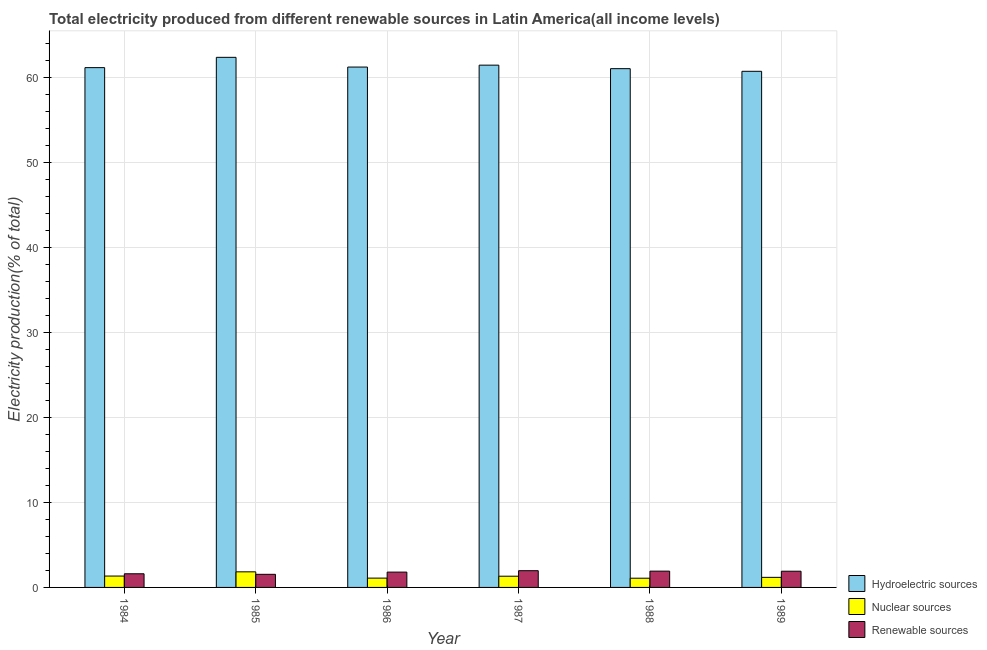How many groups of bars are there?
Your answer should be compact. 6. How many bars are there on the 3rd tick from the left?
Keep it short and to the point. 3. What is the percentage of electricity produced by hydroelectric sources in 1988?
Ensure brevity in your answer.  61.08. Across all years, what is the maximum percentage of electricity produced by nuclear sources?
Offer a terse response. 1.83. Across all years, what is the minimum percentage of electricity produced by renewable sources?
Offer a very short reply. 1.54. What is the total percentage of electricity produced by nuclear sources in the graph?
Keep it short and to the point. 7.86. What is the difference between the percentage of electricity produced by hydroelectric sources in 1985 and that in 1988?
Your answer should be very brief. 1.33. What is the difference between the percentage of electricity produced by renewable sources in 1985 and the percentage of electricity produced by nuclear sources in 1986?
Give a very brief answer. -0.26. What is the average percentage of electricity produced by renewable sources per year?
Your answer should be very brief. 1.79. In the year 1989, what is the difference between the percentage of electricity produced by hydroelectric sources and percentage of electricity produced by nuclear sources?
Provide a short and direct response. 0. In how many years, is the percentage of electricity produced by renewable sources greater than 58 %?
Keep it short and to the point. 0. What is the ratio of the percentage of electricity produced by hydroelectric sources in 1988 to that in 1989?
Offer a very short reply. 1.01. Is the percentage of electricity produced by renewable sources in 1986 less than that in 1987?
Make the answer very short. Yes. Is the difference between the percentage of electricity produced by hydroelectric sources in 1986 and 1987 greater than the difference between the percentage of electricity produced by renewable sources in 1986 and 1987?
Offer a terse response. No. What is the difference between the highest and the second highest percentage of electricity produced by hydroelectric sources?
Your response must be concise. 0.92. What is the difference between the highest and the lowest percentage of electricity produced by renewable sources?
Your answer should be very brief. 0.43. What does the 3rd bar from the left in 1985 represents?
Your response must be concise. Renewable sources. What does the 3rd bar from the right in 1987 represents?
Keep it short and to the point. Hydroelectric sources. Is it the case that in every year, the sum of the percentage of electricity produced by hydroelectric sources and percentage of electricity produced by nuclear sources is greater than the percentage of electricity produced by renewable sources?
Your response must be concise. Yes. Are all the bars in the graph horizontal?
Your answer should be compact. No. How many years are there in the graph?
Your answer should be very brief. 6. What is the difference between two consecutive major ticks on the Y-axis?
Your answer should be compact. 10. How are the legend labels stacked?
Keep it short and to the point. Vertical. What is the title of the graph?
Offer a very short reply. Total electricity produced from different renewable sources in Latin America(all income levels). Does "Fuel" appear as one of the legend labels in the graph?
Your response must be concise. No. What is the Electricity production(% of total) of Hydroelectric sources in 1984?
Keep it short and to the point. 61.2. What is the Electricity production(% of total) of Nuclear sources in 1984?
Provide a short and direct response. 1.34. What is the Electricity production(% of total) in Renewable sources in 1984?
Give a very brief answer. 1.61. What is the Electricity production(% of total) of Hydroelectric sources in 1985?
Give a very brief answer. 62.41. What is the Electricity production(% of total) of Nuclear sources in 1985?
Keep it short and to the point. 1.83. What is the Electricity production(% of total) of Renewable sources in 1985?
Make the answer very short. 1.54. What is the Electricity production(% of total) of Hydroelectric sources in 1986?
Provide a short and direct response. 61.26. What is the Electricity production(% of total) of Nuclear sources in 1986?
Your answer should be very brief. 1.1. What is the Electricity production(% of total) in Renewable sources in 1986?
Your answer should be very brief. 1.8. What is the Electricity production(% of total) in Hydroelectric sources in 1987?
Provide a short and direct response. 61.49. What is the Electricity production(% of total) in Nuclear sources in 1987?
Offer a very short reply. 1.32. What is the Electricity production(% of total) in Renewable sources in 1987?
Ensure brevity in your answer.  1.97. What is the Electricity production(% of total) of Hydroelectric sources in 1988?
Ensure brevity in your answer.  61.08. What is the Electricity production(% of total) in Nuclear sources in 1988?
Keep it short and to the point. 1.09. What is the Electricity production(% of total) of Renewable sources in 1988?
Give a very brief answer. 1.92. What is the Electricity production(% of total) of Hydroelectric sources in 1989?
Your answer should be very brief. 60.76. What is the Electricity production(% of total) of Nuclear sources in 1989?
Provide a short and direct response. 1.19. What is the Electricity production(% of total) of Renewable sources in 1989?
Offer a very short reply. 1.91. Across all years, what is the maximum Electricity production(% of total) in Hydroelectric sources?
Your response must be concise. 62.41. Across all years, what is the maximum Electricity production(% of total) in Nuclear sources?
Ensure brevity in your answer.  1.83. Across all years, what is the maximum Electricity production(% of total) in Renewable sources?
Provide a succinct answer. 1.97. Across all years, what is the minimum Electricity production(% of total) of Hydroelectric sources?
Provide a succinct answer. 60.76. Across all years, what is the minimum Electricity production(% of total) of Nuclear sources?
Your answer should be very brief. 1.09. Across all years, what is the minimum Electricity production(% of total) of Renewable sources?
Ensure brevity in your answer.  1.54. What is the total Electricity production(% of total) of Hydroelectric sources in the graph?
Your response must be concise. 368.2. What is the total Electricity production(% of total) in Nuclear sources in the graph?
Your answer should be very brief. 7.86. What is the total Electricity production(% of total) in Renewable sources in the graph?
Provide a short and direct response. 10.75. What is the difference between the Electricity production(% of total) of Hydroelectric sources in 1984 and that in 1985?
Your response must be concise. -1.21. What is the difference between the Electricity production(% of total) of Nuclear sources in 1984 and that in 1985?
Your response must be concise. -0.5. What is the difference between the Electricity production(% of total) of Renewable sources in 1984 and that in 1985?
Ensure brevity in your answer.  0.06. What is the difference between the Electricity production(% of total) in Hydroelectric sources in 1984 and that in 1986?
Keep it short and to the point. -0.07. What is the difference between the Electricity production(% of total) of Nuclear sources in 1984 and that in 1986?
Make the answer very short. 0.24. What is the difference between the Electricity production(% of total) in Renewable sources in 1984 and that in 1986?
Give a very brief answer. -0.2. What is the difference between the Electricity production(% of total) of Hydroelectric sources in 1984 and that in 1987?
Give a very brief answer. -0.29. What is the difference between the Electricity production(% of total) in Nuclear sources in 1984 and that in 1987?
Make the answer very short. 0.02. What is the difference between the Electricity production(% of total) in Renewable sources in 1984 and that in 1987?
Your answer should be compact. -0.36. What is the difference between the Electricity production(% of total) in Hydroelectric sources in 1984 and that in 1988?
Keep it short and to the point. 0.12. What is the difference between the Electricity production(% of total) in Nuclear sources in 1984 and that in 1988?
Keep it short and to the point. 0.25. What is the difference between the Electricity production(% of total) in Renewable sources in 1984 and that in 1988?
Your answer should be compact. -0.31. What is the difference between the Electricity production(% of total) in Hydroelectric sources in 1984 and that in 1989?
Keep it short and to the point. 0.43. What is the difference between the Electricity production(% of total) in Nuclear sources in 1984 and that in 1989?
Ensure brevity in your answer.  0.15. What is the difference between the Electricity production(% of total) in Renewable sources in 1984 and that in 1989?
Keep it short and to the point. -0.3. What is the difference between the Electricity production(% of total) in Hydroelectric sources in 1985 and that in 1986?
Your answer should be compact. 1.15. What is the difference between the Electricity production(% of total) in Nuclear sources in 1985 and that in 1986?
Your answer should be compact. 0.74. What is the difference between the Electricity production(% of total) of Renewable sources in 1985 and that in 1986?
Keep it short and to the point. -0.26. What is the difference between the Electricity production(% of total) of Hydroelectric sources in 1985 and that in 1987?
Provide a short and direct response. 0.92. What is the difference between the Electricity production(% of total) in Nuclear sources in 1985 and that in 1987?
Offer a very short reply. 0.52. What is the difference between the Electricity production(% of total) of Renewable sources in 1985 and that in 1987?
Provide a succinct answer. -0.43. What is the difference between the Electricity production(% of total) in Hydroelectric sources in 1985 and that in 1988?
Provide a succinct answer. 1.33. What is the difference between the Electricity production(% of total) of Nuclear sources in 1985 and that in 1988?
Your answer should be very brief. 0.75. What is the difference between the Electricity production(% of total) in Renewable sources in 1985 and that in 1988?
Give a very brief answer. -0.38. What is the difference between the Electricity production(% of total) of Hydroelectric sources in 1985 and that in 1989?
Offer a terse response. 1.65. What is the difference between the Electricity production(% of total) in Nuclear sources in 1985 and that in 1989?
Offer a terse response. 0.65. What is the difference between the Electricity production(% of total) in Renewable sources in 1985 and that in 1989?
Provide a short and direct response. -0.37. What is the difference between the Electricity production(% of total) in Hydroelectric sources in 1986 and that in 1987?
Provide a short and direct response. -0.23. What is the difference between the Electricity production(% of total) of Nuclear sources in 1986 and that in 1987?
Give a very brief answer. -0.22. What is the difference between the Electricity production(% of total) of Renewable sources in 1986 and that in 1987?
Provide a succinct answer. -0.17. What is the difference between the Electricity production(% of total) in Hydroelectric sources in 1986 and that in 1988?
Provide a short and direct response. 0.19. What is the difference between the Electricity production(% of total) of Nuclear sources in 1986 and that in 1988?
Your answer should be compact. 0.01. What is the difference between the Electricity production(% of total) in Renewable sources in 1986 and that in 1988?
Provide a short and direct response. -0.12. What is the difference between the Electricity production(% of total) of Hydroelectric sources in 1986 and that in 1989?
Provide a succinct answer. 0.5. What is the difference between the Electricity production(% of total) in Nuclear sources in 1986 and that in 1989?
Provide a short and direct response. -0.09. What is the difference between the Electricity production(% of total) in Renewable sources in 1986 and that in 1989?
Provide a succinct answer. -0.11. What is the difference between the Electricity production(% of total) of Hydroelectric sources in 1987 and that in 1988?
Give a very brief answer. 0.41. What is the difference between the Electricity production(% of total) of Nuclear sources in 1987 and that in 1988?
Give a very brief answer. 0.23. What is the difference between the Electricity production(% of total) in Renewable sources in 1987 and that in 1988?
Provide a short and direct response. 0.05. What is the difference between the Electricity production(% of total) of Hydroelectric sources in 1987 and that in 1989?
Offer a terse response. 0.73. What is the difference between the Electricity production(% of total) of Nuclear sources in 1987 and that in 1989?
Give a very brief answer. 0.13. What is the difference between the Electricity production(% of total) in Renewable sources in 1987 and that in 1989?
Provide a succinct answer. 0.06. What is the difference between the Electricity production(% of total) in Hydroelectric sources in 1988 and that in 1989?
Your answer should be very brief. 0.31. What is the difference between the Electricity production(% of total) in Nuclear sources in 1988 and that in 1989?
Provide a succinct answer. -0.1. What is the difference between the Electricity production(% of total) in Renewable sources in 1988 and that in 1989?
Provide a short and direct response. 0.01. What is the difference between the Electricity production(% of total) in Hydroelectric sources in 1984 and the Electricity production(% of total) in Nuclear sources in 1985?
Your answer should be compact. 59.36. What is the difference between the Electricity production(% of total) of Hydroelectric sources in 1984 and the Electricity production(% of total) of Renewable sources in 1985?
Your answer should be compact. 59.65. What is the difference between the Electricity production(% of total) in Nuclear sources in 1984 and the Electricity production(% of total) in Renewable sources in 1985?
Offer a terse response. -0.2. What is the difference between the Electricity production(% of total) of Hydroelectric sources in 1984 and the Electricity production(% of total) of Nuclear sources in 1986?
Your answer should be very brief. 60.1. What is the difference between the Electricity production(% of total) of Hydroelectric sources in 1984 and the Electricity production(% of total) of Renewable sources in 1986?
Offer a very short reply. 59.39. What is the difference between the Electricity production(% of total) in Nuclear sources in 1984 and the Electricity production(% of total) in Renewable sources in 1986?
Your answer should be very brief. -0.46. What is the difference between the Electricity production(% of total) of Hydroelectric sources in 1984 and the Electricity production(% of total) of Nuclear sources in 1987?
Ensure brevity in your answer.  59.88. What is the difference between the Electricity production(% of total) in Hydroelectric sources in 1984 and the Electricity production(% of total) in Renewable sources in 1987?
Keep it short and to the point. 59.23. What is the difference between the Electricity production(% of total) in Nuclear sources in 1984 and the Electricity production(% of total) in Renewable sources in 1987?
Offer a very short reply. -0.63. What is the difference between the Electricity production(% of total) of Hydroelectric sources in 1984 and the Electricity production(% of total) of Nuclear sources in 1988?
Give a very brief answer. 60.11. What is the difference between the Electricity production(% of total) of Hydroelectric sources in 1984 and the Electricity production(% of total) of Renewable sources in 1988?
Keep it short and to the point. 59.28. What is the difference between the Electricity production(% of total) in Nuclear sources in 1984 and the Electricity production(% of total) in Renewable sources in 1988?
Your response must be concise. -0.58. What is the difference between the Electricity production(% of total) in Hydroelectric sources in 1984 and the Electricity production(% of total) in Nuclear sources in 1989?
Provide a succinct answer. 60.01. What is the difference between the Electricity production(% of total) in Hydroelectric sources in 1984 and the Electricity production(% of total) in Renewable sources in 1989?
Your response must be concise. 59.29. What is the difference between the Electricity production(% of total) of Nuclear sources in 1984 and the Electricity production(% of total) of Renewable sources in 1989?
Provide a short and direct response. -0.57. What is the difference between the Electricity production(% of total) in Hydroelectric sources in 1985 and the Electricity production(% of total) in Nuclear sources in 1986?
Provide a short and direct response. 61.31. What is the difference between the Electricity production(% of total) of Hydroelectric sources in 1985 and the Electricity production(% of total) of Renewable sources in 1986?
Your response must be concise. 60.61. What is the difference between the Electricity production(% of total) in Nuclear sources in 1985 and the Electricity production(% of total) in Renewable sources in 1986?
Give a very brief answer. 0.03. What is the difference between the Electricity production(% of total) in Hydroelectric sources in 1985 and the Electricity production(% of total) in Nuclear sources in 1987?
Your answer should be compact. 61.09. What is the difference between the Electricity production(% of total) of Hydroelectric sources in 1985 and the Electricity production(% of total) of Renewable sources in 1987?
Provide a succinct answer. 60.44. What is the difference between the Electricity production(% of total) in Nuclear sources in 1985 and the Electricity production(% of total) in Renewable sources in 1987?
Your response must be concise. -0.14. What is the difference between the Electricity production(% of total) in Hydroelectric sources in 1985 and the Electricity production(% of total) in Nuclear sources in 1988?
Your answer should be very brief. 61.32. What is the difference between the Electricity production(% of total) of Hydroelectric sources in 1985 and the Electricity production(% of total) of Renewable sources in 1988?
Make the answer very short. 60.49. What is the difference between the Electricity production(% of total) in Nuclear sources in 1985 and the Electricity production(% of total) in Renewable sources in 1988?
Provide a short and direct response. -0.08. What is the difference between the Electricity production(% of total) in Hydroelectric sources in 1985 and the Electricity production(% of total) in Nuclear sources in 1989?
Your answer should be very brief. 61.22. What is the difference between the Electricity production(% of total) in Hydroelectric sources in 1985 and the Electricity production(% of total) in Renewable sources in 1989?
Make the answer very short. 60.5. What is the difference between the Electricity production(% of total) of Nuclear sources in 1985 and the Electricity production(% of total) of Renewable sources in 1989?
Give a very brief answer. -0.07. What is the difference between the Electricity production(% of total) of Hydroelectric sources in 1986 and the Electricity production(% of total) of Nuclear sources in 1987?
Offer a terse response. 59.95. What is the difference between the Electricity production(% of total) in Hydroelectric sources in 1986 and the Electricity production(% of total) in Renewable sources in 1987?
Provide a short and direct response. 59.29. What is the difference between the Electricity production(% of total) of Nuclear sources in 1986 and the Electricity production(% of total) of Renewable sources in 1987?
Give a very brief answer. -0.87. What is the difference between the Electricity production(% of total) in Hydroelectric sources in 1986 and the Electricity production(% of total) in Nuclear sources in 1988?
Offer a very short reply. 60.18. What is the difference between the Electricity production(% of total) in Hydroelectric sources in 1986 and the Electricity production(% of total) in Renewable sources in 1988?
Make the answer very short. 59.35. What is the difference between the Electricity production(% of total) of Nuclear sources in 1986 and the Electricity production(% of total) of Renewable sources in 1988?
Provide a short and direct response. -0.82. What is the difference between the Electricity production(% of total) in Hydroelectric sources in 1986 and the Electricity production(% of total) in Nuclear sources in 1989?
Your response must be concise. 60.08. What is the difference between the Electricity production(% of total) of Hydroelectric sources in 1986 and the Electricity production(% of total) of Renewable sources in 1989?
Your answer should be compact. 59.36. What is the difference between the Electricity production(% of total) in Nuclear sources in 1986 and the Electricity production(% of total) in Renewable sources in 1989?
Your answer should be very brief. -0.81. What is the difference between the Electricity production(% of total) in Hydroelectric sources in 1987 and the Electricity production(% of total) in Nuclear sources in 1988?
Your answer should be very brief. 60.4. What is the difference between the Electricity production(% of total) in Hydroelectric sources in 1987 and the Electricity production(% of total) in Renewable sources in 1988?
Make the answer very short. 59.57. What is the difference between the Electricity production(% of total) of Nuclear sources in 1987 and the Electricity production(% of total) of Renewable sources in 1988?
Give a very brief answer. -0.6. What is the difference between the Electricity production(% of total) of Hydroelectric sources in 1987 and the Electricity production(% of total) of Nuclear sources in 1989?
Provide a succinct answer. 60.3. What is the difference between the Electricity production(% of total) of Hydroelectric sources in 1987 and the Electricity production(% of total) of Renewable sources in 1989?
Offer a terse response. 59.58. What is the difference between the Electricity production(% of total) of Nuclear sources in 1987 and the Electricity production(% of total) of Renewable sources in 1989?
Give a very brief answer. -0.59. What is the difference between the Electricity production(% of total) in Hydroelectric sources in 1988 and the Electricity production(% of total) in Nuclear sources in 1989?
Provide a succinct answer. 59.89. What is the difference between the Electricity production(% of total) in Hydroelectric sources in 1988 and the Electricity production(% of total) in Renewable sources in 1989?
Make the answer very short. 59.17. What is the difference between the Electricity production(% of total) of Nuclear sources in 1988 and the Electricity production(% of total) of Renewable sources in 1989?
Offer a terse response. -0.82. What is the average Electricity production(% of total) in Hydroelectric sources per year?
Offer a very short reply. 61.37. What is the average Electricity production(% of total) of Nuclear sources per year?
Offer a very short reply. 1.31. What is the average Electricity production(% of total) in Renewable sources per year?
Provide a short and direct response. 1.79. In the year 1984, what is the difference between the Electricity production(% of total) in Hydroelectric sources and Electricity production(% of total) in Nuclear sources?
Ensure brevity in your answer.  59.86. In the year 1984, what is the difference between the Electricity production(% of total) in Hydroelectric sources and Electricity production(% of total) in Renewable sources?
Offer a terse response. 59.59. In the year 1984, what is the difference between the Electricity production(% of total) of Nuclear sources and Electricity production(% of total) of Renewable sources?
Your answer should be compact. -0.27. In the year 1985, what is the difference between the Electricity production(% of total) of Hydroelectric sources and Electricity production(% of total) of Nuclear sources?
Ensure brevity in your answer.  60.58. In the year 1985, what is the difference between the Electricity production(% of total) of Hydroelectric sources and Electricity production(% of total) of Renewable sources?
Keep it short and to the point. 60.87. In the year 1985, what is the difference between the Electricity production(% of total) of Nuclear sources and Electricity production(% of total) of Renewable sources?
Your answer should be very brief. 0.29. In the year 1986, what is the difference between the Electricity production(% of total) of Hydroelectric sources and Electricity production(% of total) of Nuclear sources?
Make the answer very short. 60.17. In the year 1986, what is the difference between the Electricity production(% of total) in Hydroelectric sources and Electricity production(% of total) in Renewable sources?
Make the answer very short. 59.46. In the year 1986, what is the difference between the Electricity production(% of total) of Nuclear sources and Electricity production(% of total) of Renewable sources?
Offer a terse response. -0.71. In the year 1987, what is the difference between the Electricity production(% of total) in Hydroelectric sources and Electricity production(% of total) in Nuclear sources?
Provide a short and direct response. 60.17. In the year 1987, what is the difference between the Electricity production(% of total) in Hydroelectric sources and Electricity production(% of total) in Renewable sources?
Make the answer very short. 59.52. In the year 1987, what is the difference between the Electricity production(% of total) of Nuclear sources and Electricity production(% of total) of Renewable sources?
Your response must be concise. -0.65. In the year 1988, what is the difference between the Electricity production(% of total) in Hydroelectric sources and Electricity production(% of total) in Nuclear sources?
Your answer should be compact. 59.99. In the year 1988, what is the difference between the Electricity production(% of total) in Hydroelectric sources and Electricity production(% of total) in Renewable sources?
Give a very brief answer. 59.16. In the year 1988, what is the difference between the Electricity production(% of total) in Nuclear sources and Electricity production(% of total) in Renewable sources?
Provide a succinct answer. -0.83. In the year 1989, what is the difference between the Electricity production(% of total) in Hydroelectric sources and Electricity production(% of total) in Nuclear sources?
Give a very brief answer. 59.58. In the year 1989, what is the difference between the Electricity production(% of total) of Hydroelectric sources and Electricity production(% of total) of Renewable sources?
Give a very brief answer. 58.85. In the year 1989, what is the difference between the Electricity production(% of total) in Nuclear sources and Electricity production(% of total) in Renewable sources?
Keep it short and to the point. -0.72. What is the ratio of the Electricity production(% of total) of Hydroelectric sources in 1984 to that in 1985?
Provide a succinct answer. 0.98. What is the ratio of the Electricity production(% of total) in Nuclear sources in 1984 to that in 1985?
Your answer should be compact. 0.73. What is the ratio of the Electricity production(% of total) of Renewable sources in 1984 to that in 1985?
Your answer should be compact. 1.04. What is the ratio of the Electricity production(% of total) in Hydroelectric sources in 1984 to that in 1986?
Give a very brief answer. 1. What is the ratio of the Electricity production(% of total) of Nuclear sources in 1984 to that in 1986?
Provide a short and direct response. 1.22. What is the ratio of the Electricity production(% of total) in Renewable sources in 1984 to that in 1986?
Offer a very short reply. 0.89. What is the ratio of the Electricity production(% of total) in Renewable sources in 1984 to that in 1987?
Offer a terse response. 0.82. What is the ratio of the Electricity production(% of total) of Nuclear sources in 1984 to that in 1988?
Offer a terse response. 1.23. What is the ratio of the Electricity production(% of total) in Renewable sources in 1984 to that in 1988?
Your answer should be compact. 0.84. What is the ratio of the Electricity production(% of total) of Hydroelectric sources in 1984 to that in 1989?
Your response must be concise. 1.01. What is the ratio of the Electricity production(% of total) of Nuclear sources in 1984 to that in 1989?
Make the answer very short. 1.13. What is the ratio of the Electricity production(% of total) in Renewable sources in 1984 to that in 1989?
Provide a short and direct response. 0.84. What is the ratio of the Electricity production(% of total) of Hydroelectric sources in 1985 to that in 1986?
Your answer should be compact. 1.02. What is the ratio of the Electricity production(% of total) of Nuclear sources in 1985 to that in 1986?
Provide a succinct answer. 1.67. What is the ratio of the Electricity production(% of total) of Renewable sources in 1985 to that in 1986?
Your answer should be very brief. 0.86. What is the ratio of the Electricity production(% of total) of Hydroelectric sources in 1985 to that in 1987?
Provide a short and direct response. 1.01. What is the ratio of the Electricity production(% of total) in Nuclear sources in 1985 to that in 1987?
Provide a succinct answer. 1.39. What is the ratio of the Electricity production(% of total) of Renewable sources in 1985 to that in 1987?
Your answer should be compact. 0.78. What is the ratio of the Electricity production(% of total) in Hydroelectric sources in 1985 to that in 1988?
Your answer should be very brief. 1.02. What is the ratio of the Electricity production(% of total) in Nuclear sources in 1985 to that in 1988?
Provide a short and direct response. 1.69. What is the ratio of the Electricity production(% of total) of Renewable sources in 1985 to that in 1988?
Your response must be concise. 0.8. What is the ratio of the Electricity production(% of total) in Hydroelectric sources in 1985 to that in 1989?
Provide a short and direct response. 1.03. What is the ratio of the Electricity production(% of total) in Nuclear sources in 1985 to that in 1989?
Your answer should be compact. 1.55. What is the ratio of the Electricity production(% of total) of Renewable sources in 1985 to that in 1989?
Offer a very short reply. 0.81. What is the ratio of the Electricity production(% of total) in Hydroelectric sources in 1986 to that in 1987?
Offer a very short reply. 1. What is the ratio of the Electricity production(% of total) of Nuclear sources in 1986 to that in 1987?
Your answer should be compact. 0.83. What is the ratio of the Electricity production(% of total) of Renewable sources in 1986 to that in 1987?
Make the answer very short. 0.92. What is the ratio of the Electricity production(% of total) in Nuclear sources in 1986 to that in 1988?
Provide a short and direct response. 1.01. What is the ratio of the Electricity production(% of total) of Renewable sources in 1986 to that in 1988?
Keep it short and to the point. 0.94. What is the ratio of the Electricity production(% of total) in Hydroelectric sources in 1986 to that in 1989?
Your answer should be very brief. 1.01. What is the ratio of the Electricity production(% of total) in Nuclear sources in 1986 to that in 1989?
Offer a terse response. 0.92. What is the ratio of the Electricity production(% of total) of Renewable sources in 1986 to that in 1989?
Keep it short and to the point. 0.94. What is the ratio of the Electricity production(% of total) of Hydroelectric sources in 1987 to that in 1988?
Provide a short and direct response. 1.01. What is the ratio of the Electricity production(% of total) in Nuclear sources in 1987 to that in 1988?
Make the answer very short. 1.22. What is the ratio of the Electricity production(% of total) in Renewable sources in 1987 to that in 1988?
Your answer should be very brief. 1.03. What is the ratio of the Electricity production(% of total) in Nuclear sources in 1987 to that in 1989?
Provide a succinct answer. 1.11. What is the ratio of the Electricity production(% of total) in Renewable sources in 1987 to that in 1989?
Provide a succinct answer. 1.03. What is the ratio of the Electricity production(% of total) in Nuclear sources in 1988 to that in 1989?
Give a very brief answer. 0.92. What is the difference between the highest and the second highest Electricity production(% of total) of Hydroelectric sources?
Make the answer very short. 0.92. What is the difference between the highest and the second highest Electricity production(% of total) in Nuclear sources?
Offer a terse response. 0.5. What is the difference between the highest and the second highest Electricity production(% of total) in Renewable sources?
Offer a terse response. 0.05. What is the difference between the highest and the lowest Electricity production(% of total) in Hydroelectric sources?
Give a very brief answer. 1.65. What is the difference between the highest and the lowest Electricity production(% of total) of Nuclear sources?
Provide a succinct answer. 0.75. What is the difference between the highest and the lowest Electricity production(% of total) of Renewable sources?
Provide a succinct answer. 0.43. 